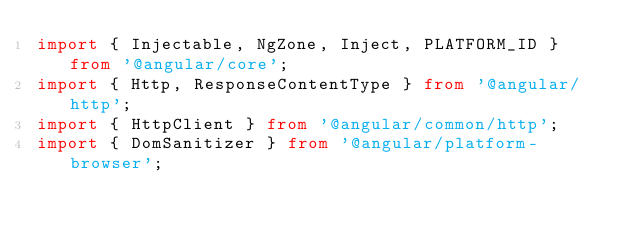<code> <loc_0><loc_0><loc_500><loc_500><_TypeScript_>import { Injectable, NgZone, Inject, PLATFORM_ID } from '@angular/core';
import { Http, ResponseContentType } from '@angular/http';
import { HttpClient } from '@angular/common/http';
import { DomSanitizer } from '@angular/platform-browser';
</code> 